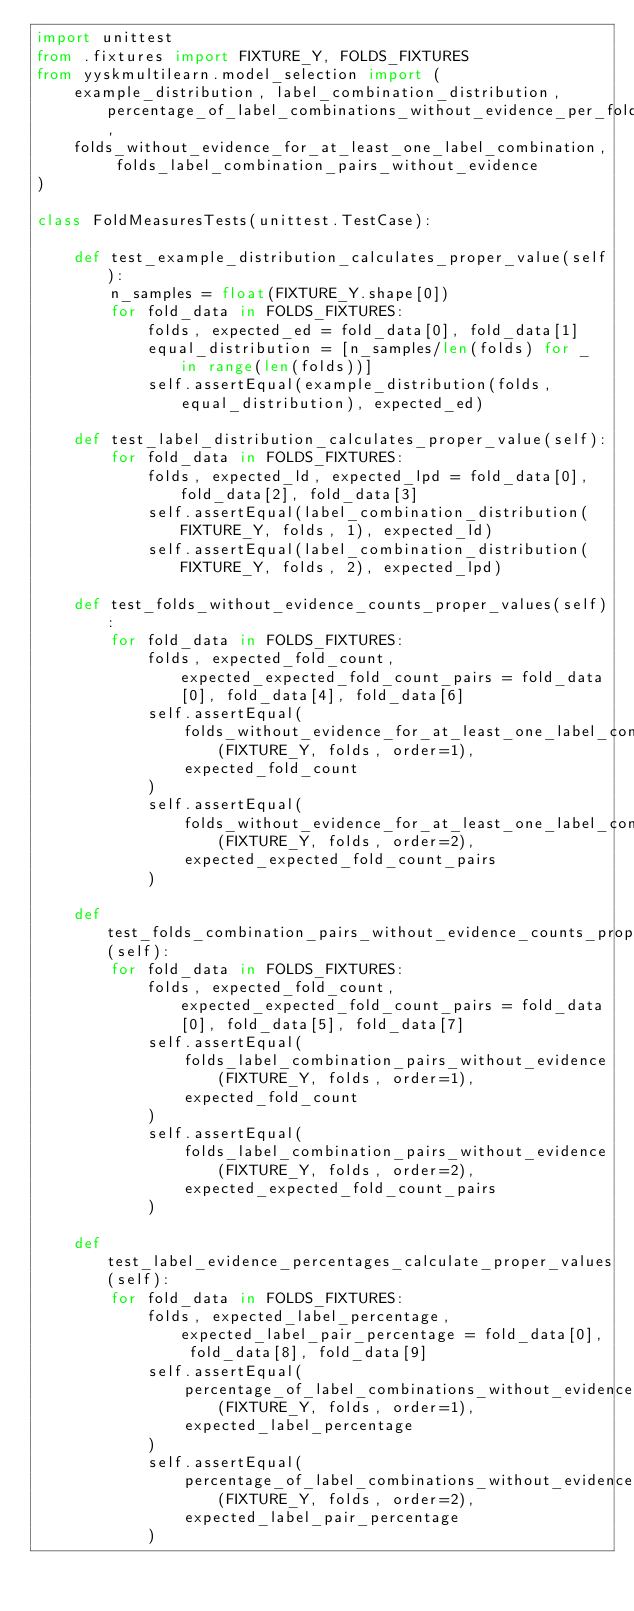<code> <loc_0><loc_0><loc_500><loc_500><_Python_>import unittest
from .fixtures import FIXTURE_Y, FOLDS_FIXTURES
from yyskmultilearn.model_selection import (
    example_distribution, label_combination_distribution, percentage_of_label_combinations_without_evidence_per_fold,
    folds_without_evidence_for_at_least_one_label_combination, folds_label_combination_pairs_without_evidence
)

class FoldMeasuresTests(unittest.TestCase):

    def test_example_distribution_calculates_proper_value(self):
        n_samples = float(FIXTURE_Y.shape[0])
        for fold_data in FOLDS_FIXTURES:
            folds, expected_ed = fold_data[0], fold_data[1]
            equal_distribution = [n_samples/len(folds) for _ in range(len(folds))]
            self.assertEqual(example_distribution(folds, equal_distribution), expected_ed)

    def test_label_distribution_calculates_proper_value(self):
        for fold_data in FOLDS_FIXTURES:
            folds, expected_ld, expected_lpd = fold_data[0], fold_data[2], fold_data[3]
            self.assertEqual(label_combination_distribution(FIXTURE_Y, folds, 1), expected_ld)
            self.assertEqual(label_combination_distribution(FIXTURE_Y, folds, 2), expected_lpd)

    def test_folds_without_evidence_counts_proper_values(self):
        for fold_data in FOLDS_FIXTURES:
            folds, expected_fold_count, expected_expected_fold_count_pairs = fold_data[0], fold_data[4], fold_data[6]
            self.assertEqual(
                folds_without_evidence_for_at_least_one_label_combination(FIXTURE_Y, folds, order=1),
                expected_fold_count
            )
            self.assertEqual(
                folds_without_evidence_for_at_least_one_label_combination(FIXTURE_Y, folds, order=2),
                expected_expected_fold_count_pairs
            )

    def test_folds_combination_pairs_without_evidence_counts_proper_values(self):
        for fold_data in FOLDS_FIXTURES:
            folds, expected_fold_count, expected_expected_fold_count_pairs = fold_data[0], fold_data[5], fold_data[7]
            self.assertEqual(
                folds_label_combination_pairs_without_evidence(FIXTURE_Y, folds, order=1),
                expected_fold_count
            )
            self.assertEqual(
                folds_label_combination_pairs_without_evidence(FIXTURE_Y, folds, order=2),
                expected_expected_fold_count_pairs
            )

    def test_label_evidence_percentages_calculate_proper_values(self):
        for fold_data in FOLDS_FIXTURES:
            folds, expected_label_percentage, expected_label_pair_percentage = fold_data[0], fold_data[8], fold_data[9]
            self.assertEqual(
                percentage_of_label_combinations_without_evidence_per_fold(FIXTURE_Y, folds, order=1),
                expected_label_percentage
            )
            self.assertEqual(
                percentage_of_label_combinations_without_evidence_per_fold(FIXTURE_Y, folds, order=2),
                expected_label_pair_percentage
            )</code> 